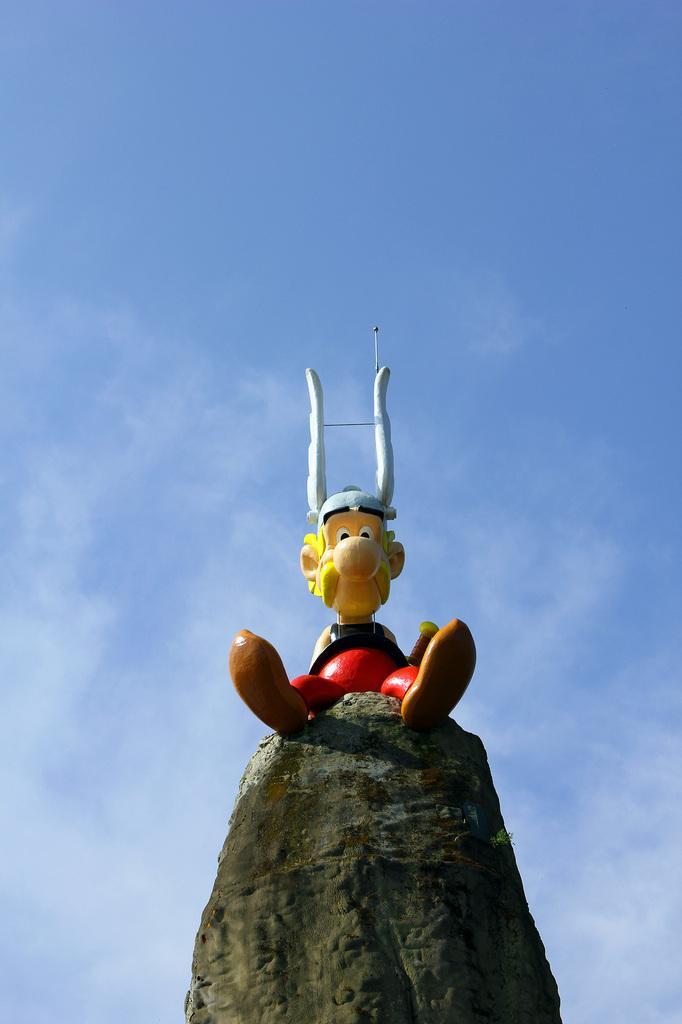Please provide a concise description of this image. It is a toy in the shape of a man on a rock. At the top it's a blue color sky. 